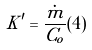Convert formula to latex. <formula><loc_0><loc_0><loc_500><loc_500>K ^ { \prime } = \frac { \dot { m } } { C _ { o } } ( 4 )</formula> 